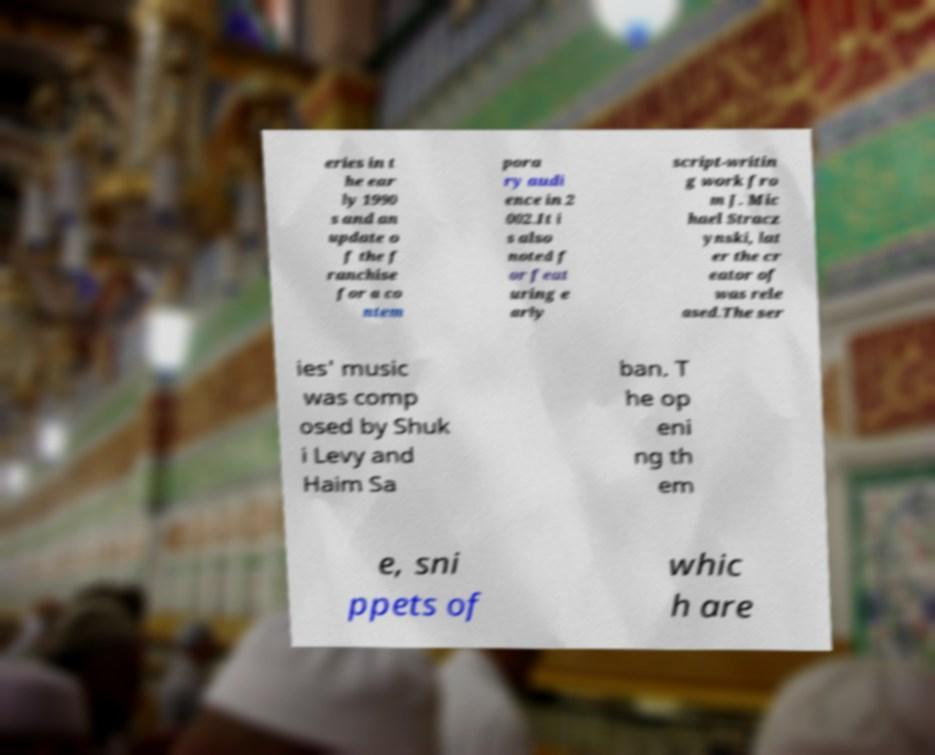I need the written content from this picture converted into text. Can you do that? eries in t he ear ly 1990 s and an update o f the f ranchise for a co ntem pora ry audi ence in 2 002.It i s also noted f or feat uring e arly script-writin g work fro m J. Mic hael Stracz ynski, lat er the cr eator of was rele ased.The ser ies' music was comp osed by Shuk i Levy and Haim Sa ban. T he op eni ng th em e, sni ppets of whic h are 